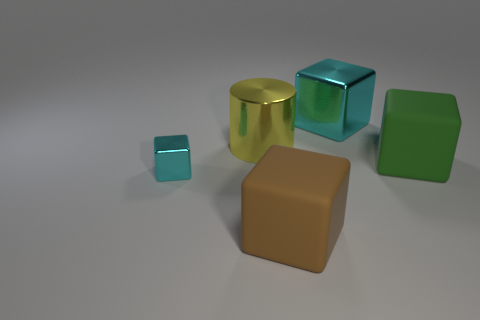Without altering their position, which two objects could create a stack with the smallest footprint? The golden cylinder and the large brown cube could be stacked together to create a stack with the smallest footprint, as their faces are similar in size and they can align vertically. 